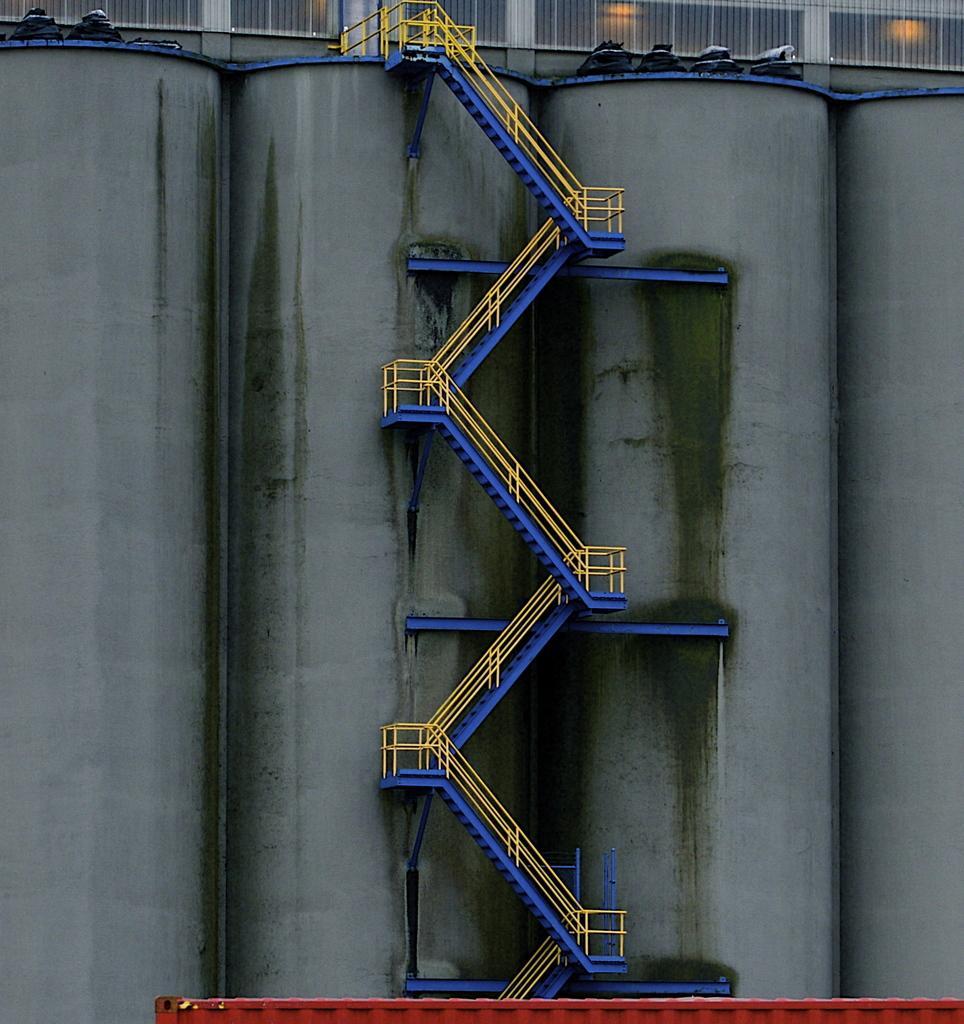Describe this image in one or two sentences. In this picture we can see a staircase, wall, fence, lights and some objects. 